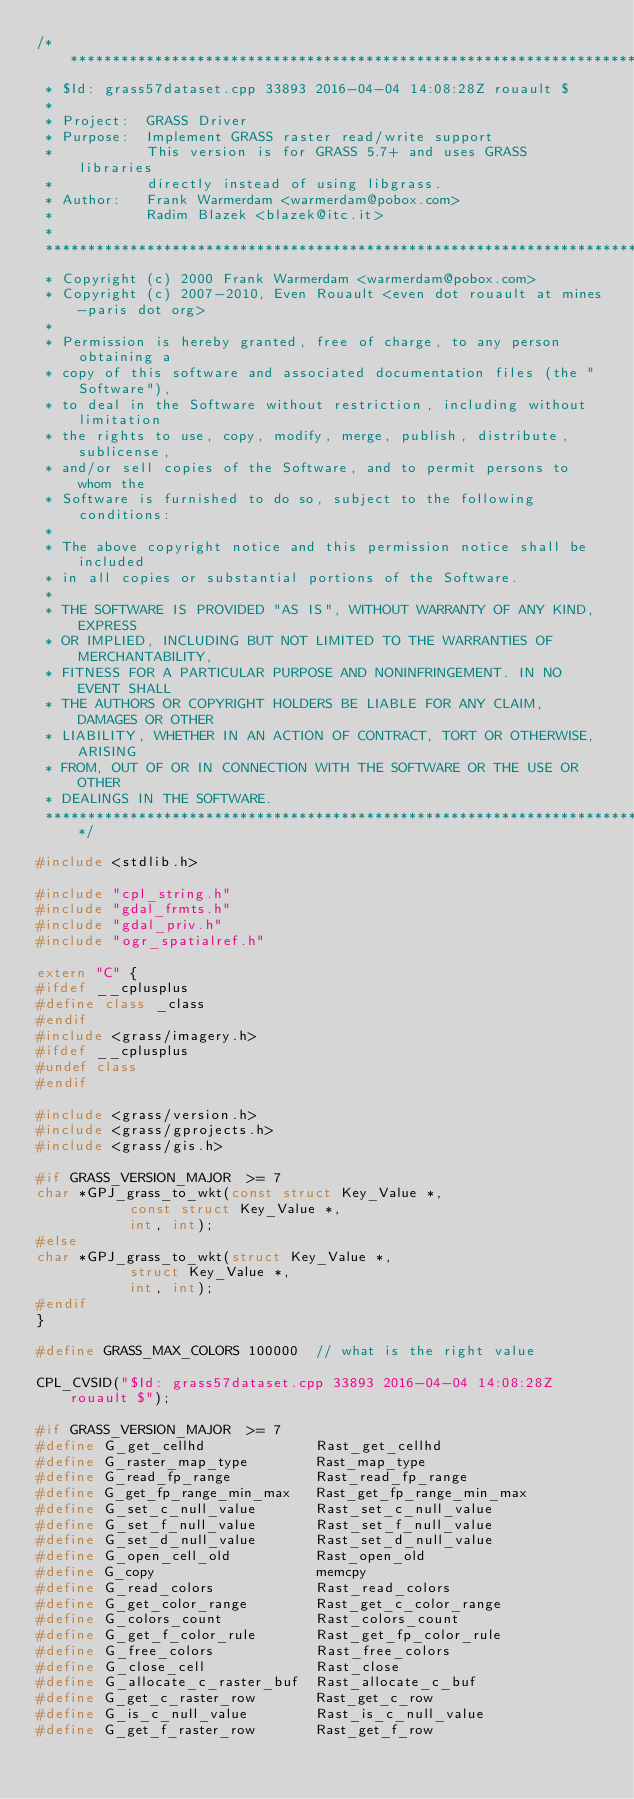Convert code to text. <code><loc_0><loc_0><loc_500><loc_500><_C++_>/******************************************************************************
 * $Id: grass57dataset.cpp 33893 2016-04-04 14:08:28Z rouault $
 *
 * Project:  GRASS Driver
 * Purpose:  Implement GRASS raster read/write support
 *           This version is for GRASS 5.7+ and uses GRASS libraries
 *           directly instead of using libgrass.
 * Author:   Frank Warmerdam <warmerdam@pobox.com>
 *           Radim Blazek <blazek@itc.it>
 *
 ******************************************************************************
 * Copyright (c) 2000 Frank Warmerdam <warmerdam@pobox.com>
 * Copyright (c) 2007-2010, Even Rouault <even dot rouault at mines-paris dot org>
 *
 * Permission is hereby granted, free of charge, to any person obtaining a
 * copy of this software and associated documentation files (the "Software"),
 * to deal in the Software without restriction, including without limitation
 * the rights to use, copy, modify, merge, publish, distribute, sublicense,
 * and/or sell copies of the Software, and to permit persons to whom the
 * Software is furnished to do so, subject to the following conditions:
 *
 * The above copyright notice and this permission notice shall be included
 * in all copies or substantial portions of the Software.
 *
 * THE SOFTWARE IS PROVIDED "AS IS", WITHOUT WARRANTY OF ANY KIND, EXPRESS
 * OR IMPLIED, INCLUDING BUT NOT LIMITED TO THE WARRANTIES OF MERCHANTABILITY,
 * FITNESS FOR A PARTICULAR PURPOSE AND NONINFRINGEMENT. IN NO EVENT SHALL
 * THE AUTHORS OR COPYRIGHT HOLDERS BE LIABLE FOR ANY CLAIM, DAMAGES OR OTHER
 * LIABILITY, WHETHER IN AN ACTION OF CONTRACT, TORT OR OTHERWISE, ARISING
 * FROM, OUT OF OR IN CONNECTION WITH THE SOFTWARE OR THE USE OR OTHER
 * DEALINGS IN THE SOFTWARE.
 ****************************************************************************/

#include <stdlib.h>

#include "cpl_string.h"
#include "gdal_frmts.h"
#include "gdal_priv.h"
#include "ogr_spatialref.h"

extern "C" {
#ifdef __cplusplus
#define class _class
#endif
#include <grass/imagery.h>
#ifdef __cplusplus
#undef class
#endif

#include <grass/version.h>
#include <grass/gprojects.h>
#include <grass/gis.h>

#if GRASS_VERSION_MAJOR  >= 7
char *GPJ_grass_to_wkt(const struct Key_Value *,
		       const struct Key_Value *,
		       int, int);
#else
char *GPJ_grass_to_wkt(struct Key_Value *,
		       struct Key_Value *,
		       int, int);
#endif
}

#define GRASS_MAX_COLORS 100000  // what is the right value

CPL_CVSID("$Id: grass57dataset.cpp 33893 2016-04-04 14:08:28Z rouault $");

#if GRASS_VERSION_MAJOR  >= 7
#define G_get_cellhd             Rast_get_cellhd
#define G_raster_map_type        Rast_map_type
#define G_read_fp_range          Rast_read_fp_range
#define G_get_fp_range_min_max   Rast_get_fp_range_min_max
#define G_set_c_null_value       Rast_set_c_null_value
#define G_set_f_null_value       Rast_set_f_null_value
#define G_set_d_null_value       Rast_set_d_null_value
#define G_open_cell_old          Rast_open_old
#define G_copy                   memcpy
#define G_read_colors            Rast_read_colors
#define G_get_color_range        Rast_get_c_color_range
#define G_colors_count           Rast_colors_count
#define G_get_f_color_rule       Rast_get_fp_color_rule
#define G_free_colors            Rast_free_colors
#define G_close_cell             Rast_close
#define G_allocate_c_raster_buf  Rast_allocate_c_buf
#define G_get_c_raster_row       Rast_get_c_row
#define G_is_c_null_value        Rast_is_c_null_value
#define G_get_f_raster_row       Rast_get_f_row</code> 